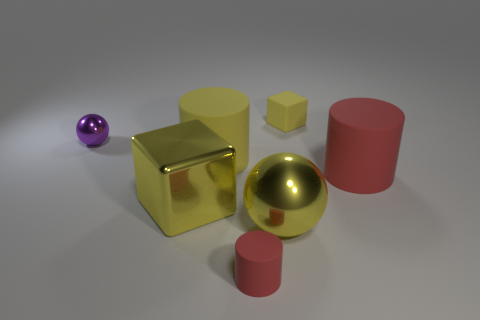There is another block that is the same color as the metal cube; what is its size?
Your response must be concise. Small. Is the color of the small cylinder the same as the big cylinder that is to the right of the large sphere?
Provide a short and direct response. Yes. Are there any tiny red things on the left side of the rubber block?
Provide a short and direct response. Yes. There is a thing that is behind the tiny purple object; is it the same size as the cube that is in front of the big red object?
Keep it short and to the point. No. Are there any brown matte cylinders that have the same size as the matte cube?
Keep it short and to the point. No. Is the shape of the big shiny thing right of the small red object the same as  the tiny red matte thing?
Provide a short and direct response. No. What is the big yellow cube that is in front of the tiny yellow matte thing made of?
Keep it short and to the point. Metal. The red matte thing to the left of the metal sphere that is to the right of the purple shiny sphere is what shape?
Your answer should be compact. Cylinder. There is a large red rubber object; is it the same shape as the tiny red matte thing that is in front of the large yellow cylinder?
Give a very brief answer. Yes. There is a yellow block behind the purple thing; how many small matte things are behind it?
Make the answer very short. 0. 